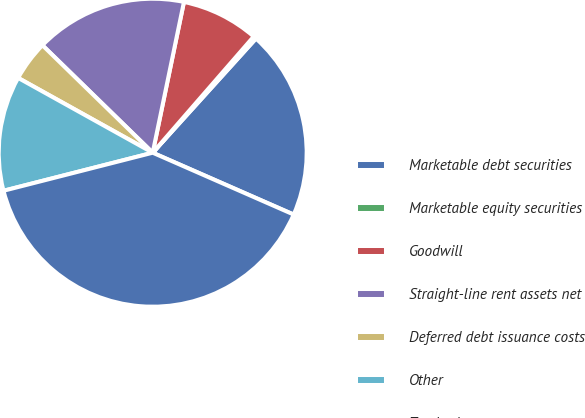Convert chart to OTSL. <chart><loc_0><loc_0><loc_500><loc_500><pie_chart><fcel>Marketable debt securities<fcel>Marketable equity securities<fcel>Goodwill<fcel>Straight-line rent assets net<fcel>Deferred debt issuance costs<fcel>Other<fcel>Total other assets<nl><fcel>19.88%<fcel>0.31%<fcel>8.14%<fcel>15.96%<fcel>4.22%<fcel>12.05%<fcel>39.45%<nl></chart> 